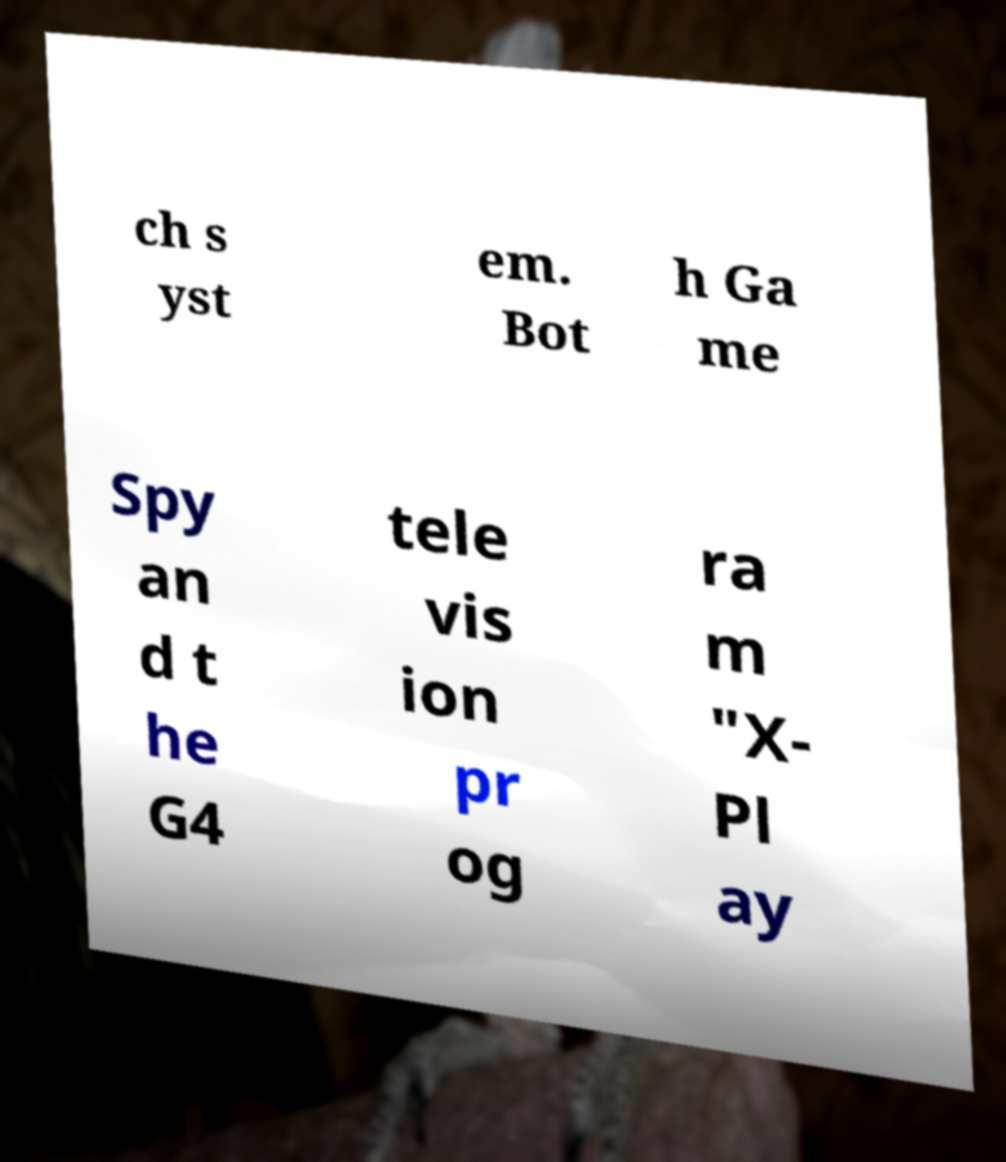Can you read and provide the text displayed in the image?This photo seems to have some interesting text. Can you extract and type it out for me? ch s yst em. Bot h Ga me Spy an d t he G4 tele vis ion pr og ra m "X- Pl ay 